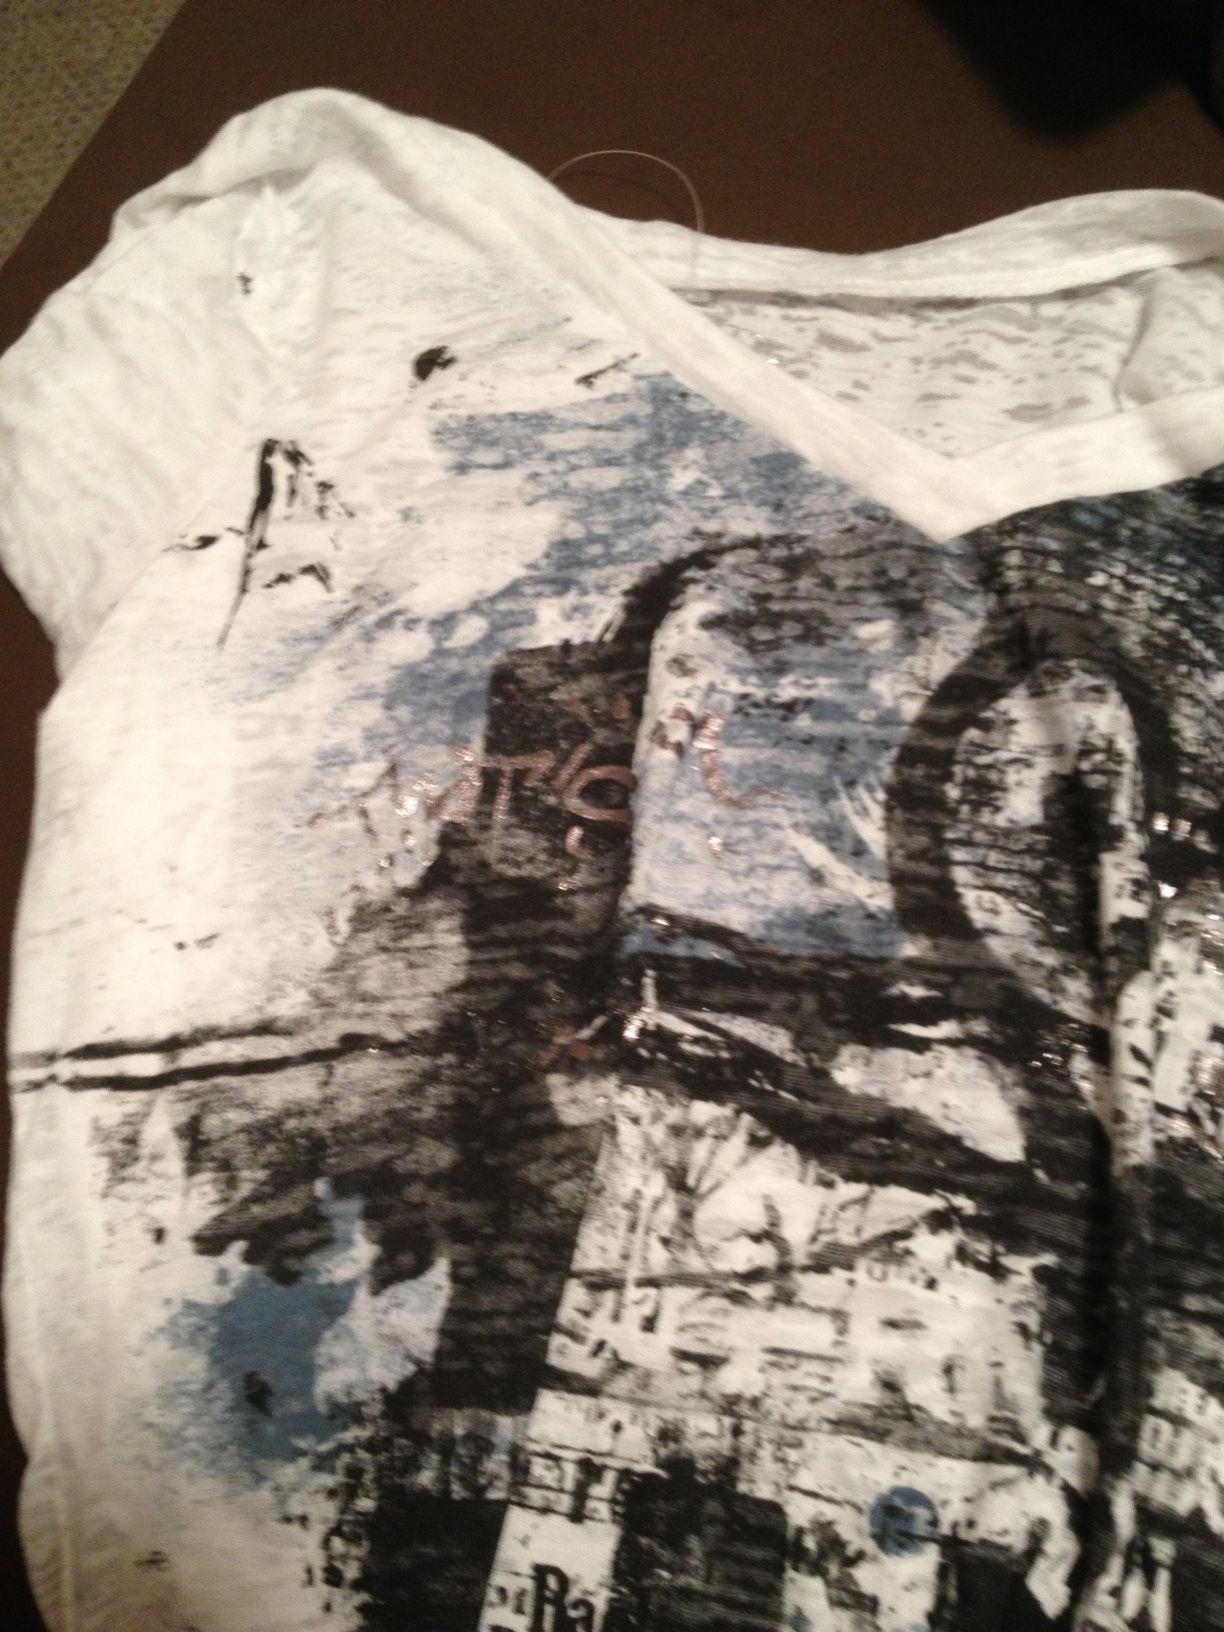Imagine the wearer of this shirt is describing their favorite season and why this shirt represents it. What might they say? The wearer might say, 'My favorite season is autumn, and this shirt represents it perfectly. The abstract design with its mix of dark and light colors reminds me of the transition from summer to winter, where everything is in a state of change. The bold, chaotic strokes symbolize the gusty winds and falling leaves, while the softer blue and white tones evoke the crisp yet serene atmosphere of the autumn sky. It's a perfect representation of the beauty and unpredictability of my favorite season.' 